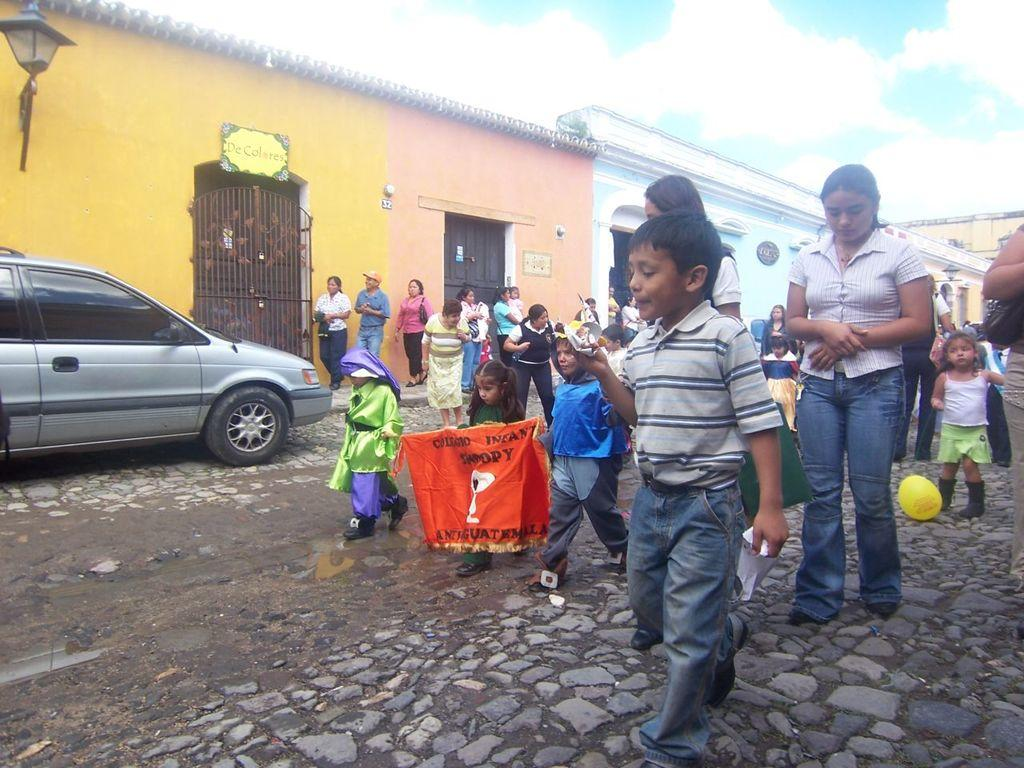Who is present in the image? There are persons in the image, including kids. What are the kids doing in the image? The kids are walking on the road. Can you describe the vehicle in the image? There is a car parked at the left side of the image. What type of structures can be seen in the image? There are buildings in the image, and they have doors. How is the weather in the image? The sky is clear in the image, suggesting good weather. What type of sail can be seen on the buildings in the image? There are no sails present on the buildings in the image. How does the prose in the image contribute to the comfort of the persons? There is no prose present in the image, and therefore it cannot contribute to the comfort of the persons. 